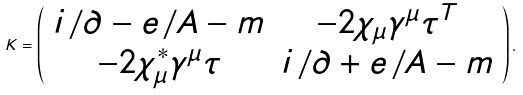<formula> <loc_0><loc_0><loc_500><loc_500>K = \left ( \begin{array} { c c } i { \not \, \partial } - e { \not \, A } - m & - 2 \chi _ { \mu } \gamma ^ { \mu } \tau ^ { T } \\ - 2 \chi ^ { * } _ { \mu } \gamma ^ { \mu } \tau & i { \not \, \partial } + e { \not \, A } - m \end{array} \right ) .</formula> 